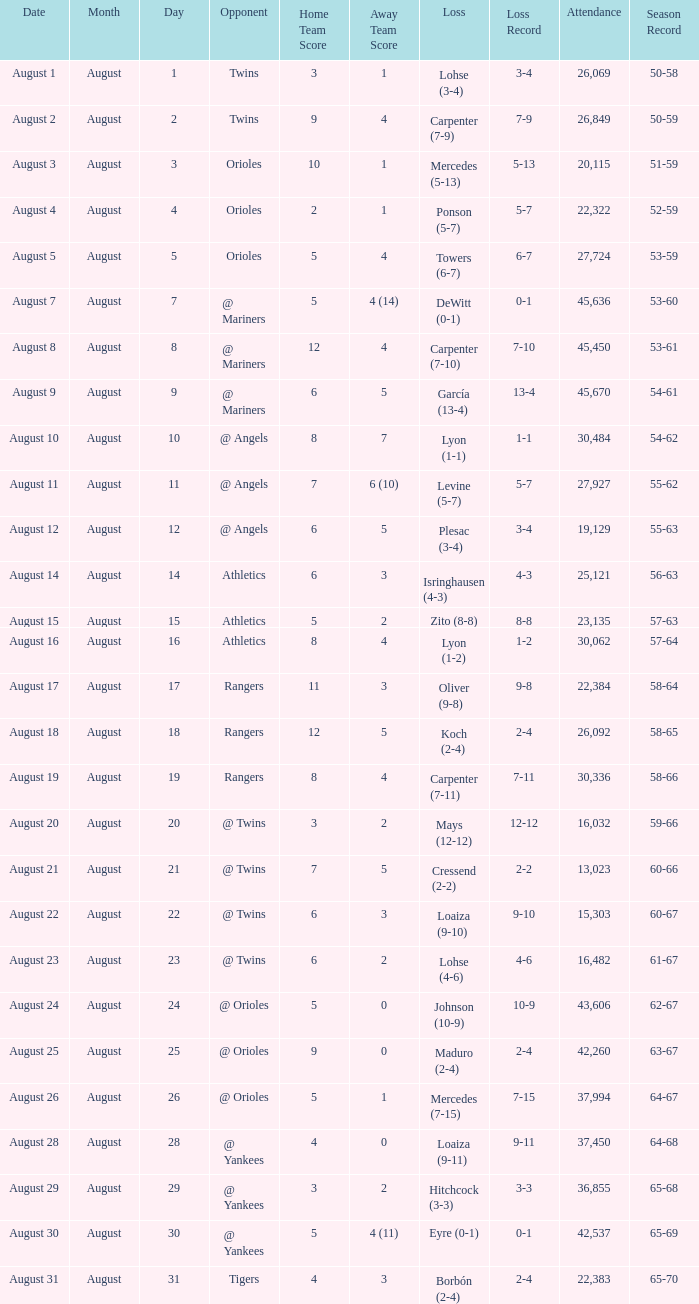What was the score of the game when their record was 62-67 5 - 0. 